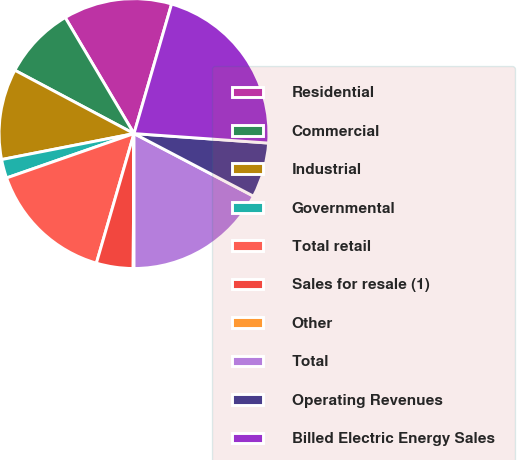<chart> <loc_0><loc_0><loc_500><loc_500><pie_chart><fcel>Residential<fcel>Commercial<fcel>Industrial<fcel>Governmental<fcel>Total retail<fcel>Sales for resale (1)<fcel>Other<fcel>Total<fcel>Operating Revenues<fcel>Billed Electric Energy Sales<nl><fcel>13.01%<fcel>8.71%<fcel>10.86%<fcel>2.25%<fcel>15.17%<fcel>4.4%<fcel>0.1%<fcel>17.32%<fcel>6.56%<fcel>21.63%<nl></chart> 